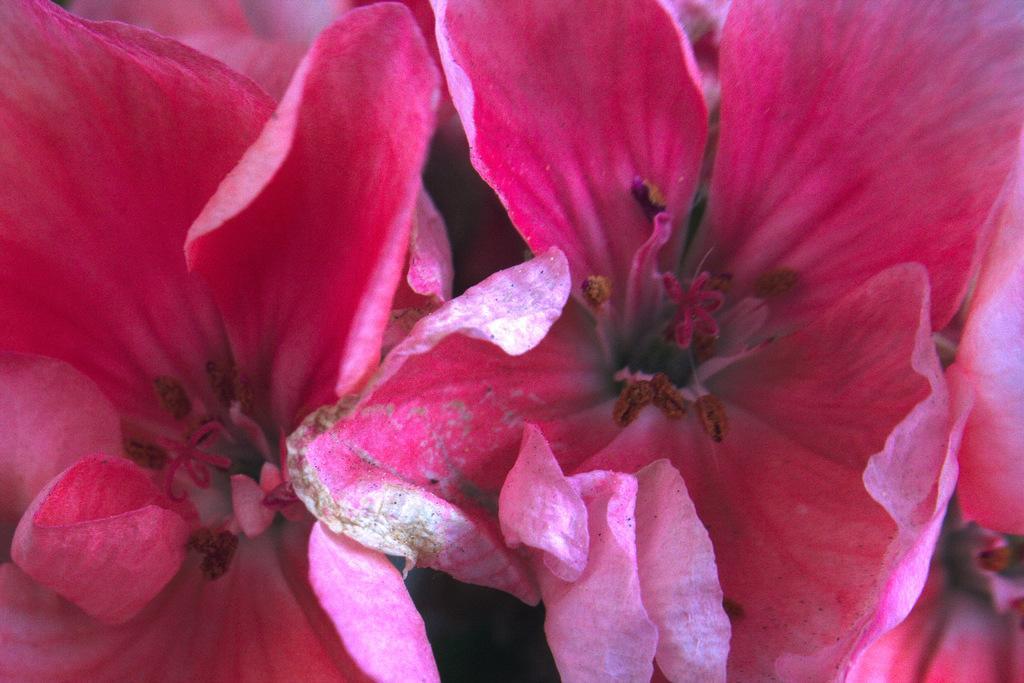Please provide a concise description of this image. In the image we can see some pink color flowers. 